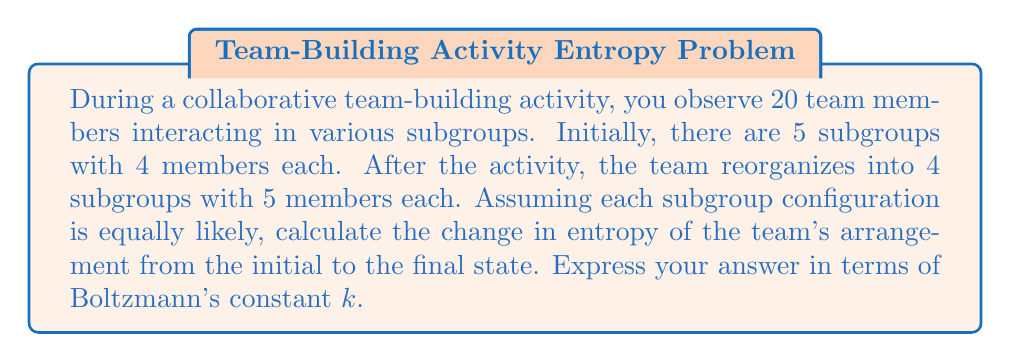Can you solve this math problem? To solve this problem, we'll use the concept of entropy from statistical mechanics and apply it to team dynamics. We'll follow these steps:

1. Calculate the number of microstates for the initial configuration
2. Calculate the number of microstates for the final configuration
3. Calculate the entropy for both configurations
4. Determine the change in entropy

Step 1: Initial configuration microstates
* 20 team members divided into 5 subgroups of 4
* Number of ways to arrange this: $\Omega_i = \frac{20!}{(4!)^5}$

Step 2: Final configuration microstates
* 20 team members divided into 4 subgroups of 5
* Number of ways to arrange this: $\Omega_f = \frac{20!}{(5!)^4}$

Step 3: Entropy calculations
* Entropy is given by $S = k \ln \Omega$
* Initial entropy: $S_i = k \ln (\frac{20!}{(4!)^5})$
* Final entropy: $S_f = k \ln (\frac{20!}{(5!)^4})$

Step 4: Change in entropy
* $\Delta S = S_f - S_i$
* $\Delta S = k \ln (\frac{20!}{(5!)^4}) - k \ln (\frac{20!}{(4!)^5})$
* $\Delta S = k \ln (\frac{(4!)^5}{(5!)^4})$

Simplifying:
* $(4!)^5 = (24)^5 = 7,962,624$
* $(5!)^4 = (120)^4 = 207,360,000$
* $\frac{(4!)^5}{(5!)^4} = \frac{7,962,624}{207,360,000} \approx 0.0384$

Therefore, $\Delta S = k \ln (0.0384) \approx -3.26k$
Answer: $-3.26k$ 